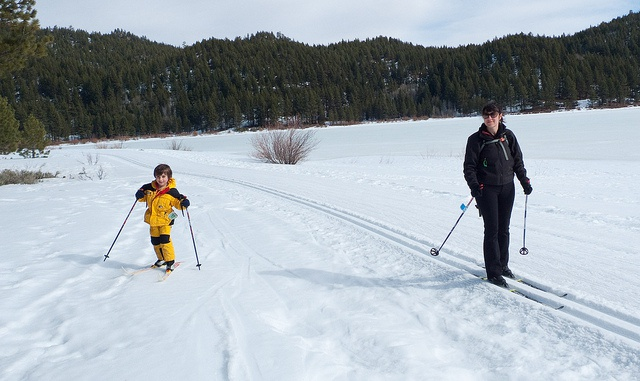Describe the objects in this image and their specific colors. I can see people in black, gray, and brown tones, people in black, orange, olive, and maroon tones, skis in black, darkgray, lightgray, and gray tones, and skis in black, lightgray, pink, and darkgray tones in this image. 